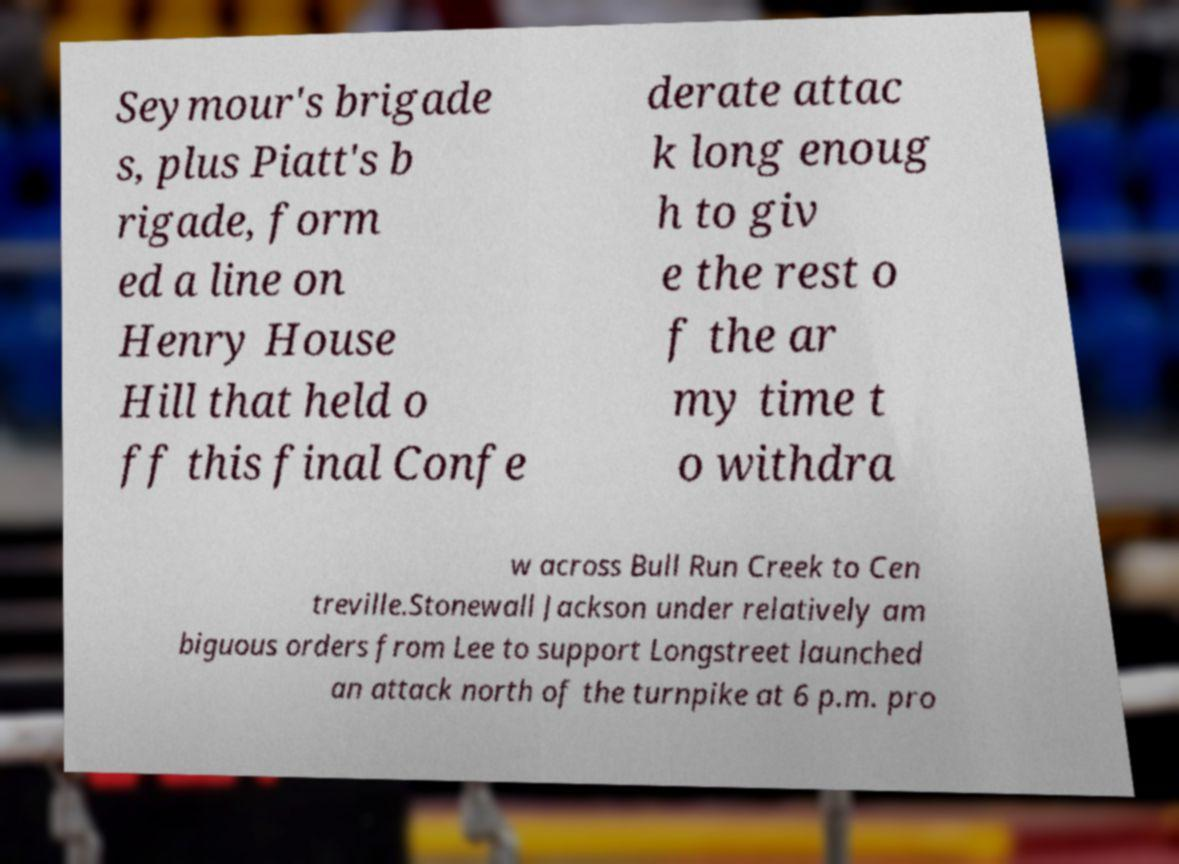What messages or text are displayed in this image? I need them in a readable, typed format. Seymour's brigade s, plus Piatt's b rigade, form ed a line on Henry House Hill that held o ff this final Confe derate attac k long enoug h to giv e the rest o f the ar my time t o withdra w across Bull Run Creek to Cen treville.Stonewall Jackson under relatively am biguous orders from Lee to support Longstreet launched an attack north of the turnpike at 6 p.m. pro 